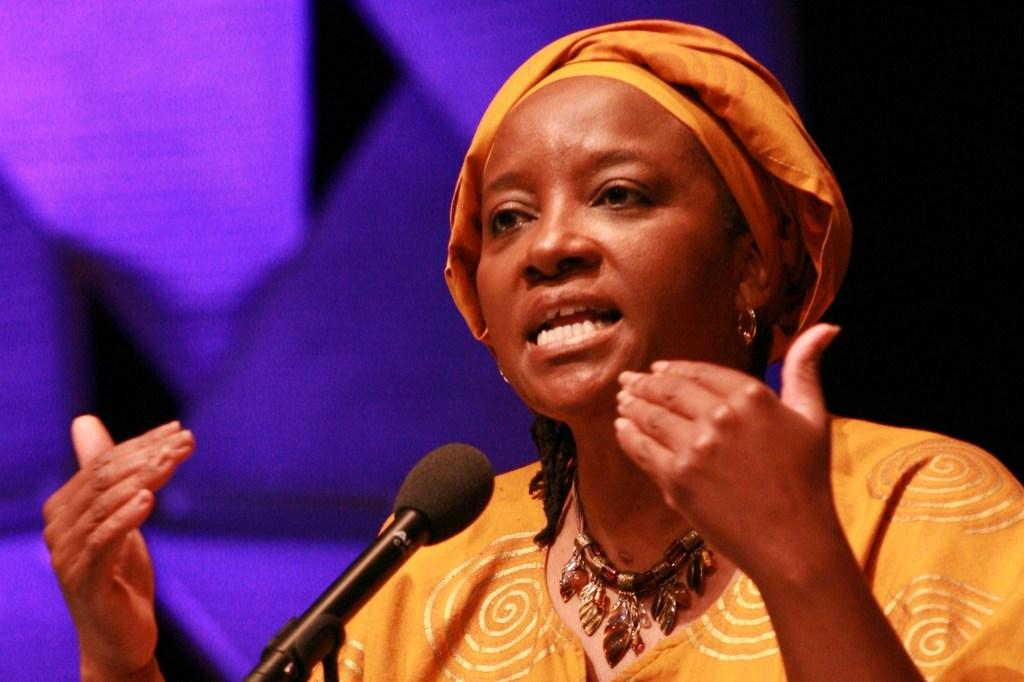Who is the main subject in the image? There is a lady in the center of the image. What is the lady doing in the image? The lady is standing in front of a mic and talking. What is the color of the background in the image? The background of the image is blue in color. How would you describe the lighting on the right side of the image? The right side of the image is dark. What type of linen is being used by the lady in the image? There is no linen present in the image; the lady is standing in front of a mic and talking. What is the lady's mother doing in the image? There is no mention of the lady's mother in the image; the lady is the main subject. 